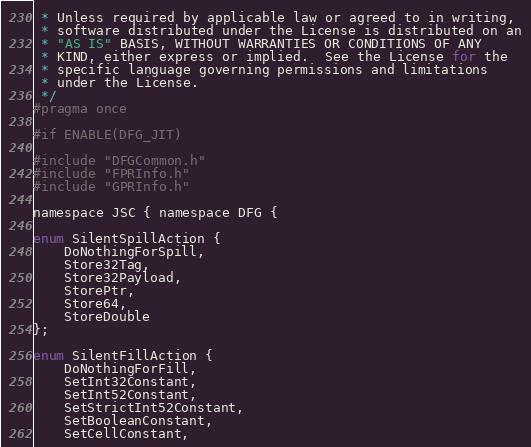<code> <loc_0><loc_0><loc_500><loc_500><_C_> * Unless required by applicable law or agreed to in writing,
 * software distributed under the License is distributed on an
 * "AS IS" BASIS, WITHOUT WARRANTIES OR CONDITIONS OF ANY
 * KIND, either express or implied.  See the License for the
 * specific language governing permissions and limitations
 * under the License.
 */
#pragma once

#if ENABLE(DFG_JIT)

#include "DFGCommon.h"
#include "FPRInfo.h"
#include "GPRInfo.h"

namespace JSC { namespace DFG {

enum SilentSpillAction {
    DoNothingForSpill,
    Store32Tag,
    Store32Payload,
    StorePtr,
    Store64,
    StoreDouble
};

enum SilentFillAction {
    DoNothingForFill,
    SetInt32Constant,
    SetInt52Constant,
    SetStrictInt52Constant,
    SetBooleanConstant,
    SetCellConstant,</code> 